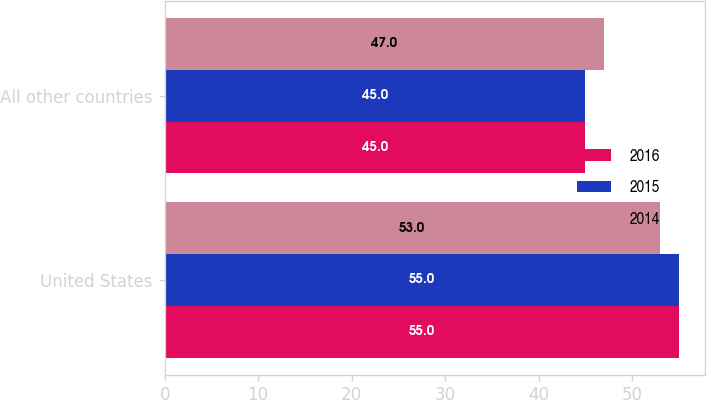Convert chart. <chart><loc_0><loc_0><loc_500><loc_500><stacked_bar_chart><ecel><fcel>United States<fcel>All other countries<nl><fcel>2016<fcel>55<fcel>45<nl><fcel>2015<fcel>55<fcel>45<nl><fcel>2014<fcel>53<fcel>47<nl></chart> 